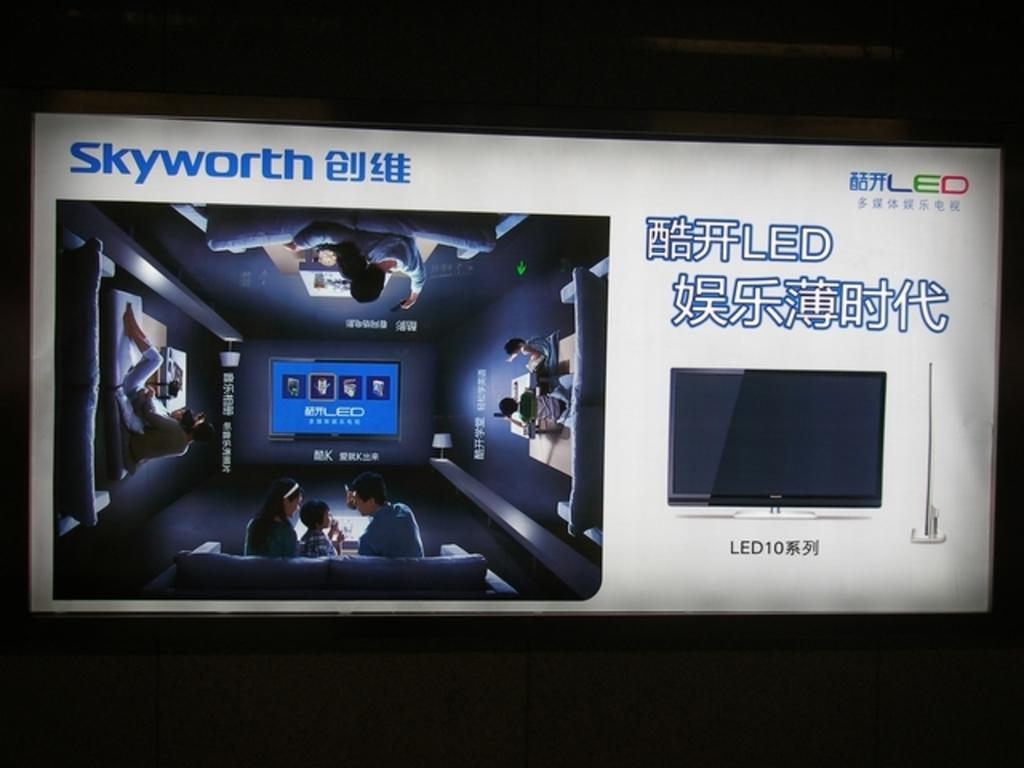<image>
Create a compact narrative representing the image presented. A screen is showing a family in a home theater and says Skyworth LED. 